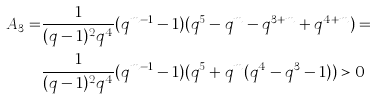Convert formula to latex. <formula><loc_0><loc_0><loc_500><loc_500>A _ { 3 } = & \frac { 1 } { ( q - 1 ) ^ { 2 } q ^ { 4 } } ( q ^ { m - 1 } - 1 ) ( q ^ { 5 } - q ^ { m } - q ^ { 3 + m } + q ^ { 4 + m } ) = \\ & \frac { 1 } { ( q - 1 ) ^ { 2 } q ^ { 4 } } ( q ^ { m - 1 } - 1 ) ( q ^ { 5 } + q ^ { m } ( q ^ { 4 } - q ^ { 3 } - 1 ) ) > 0</formula> 